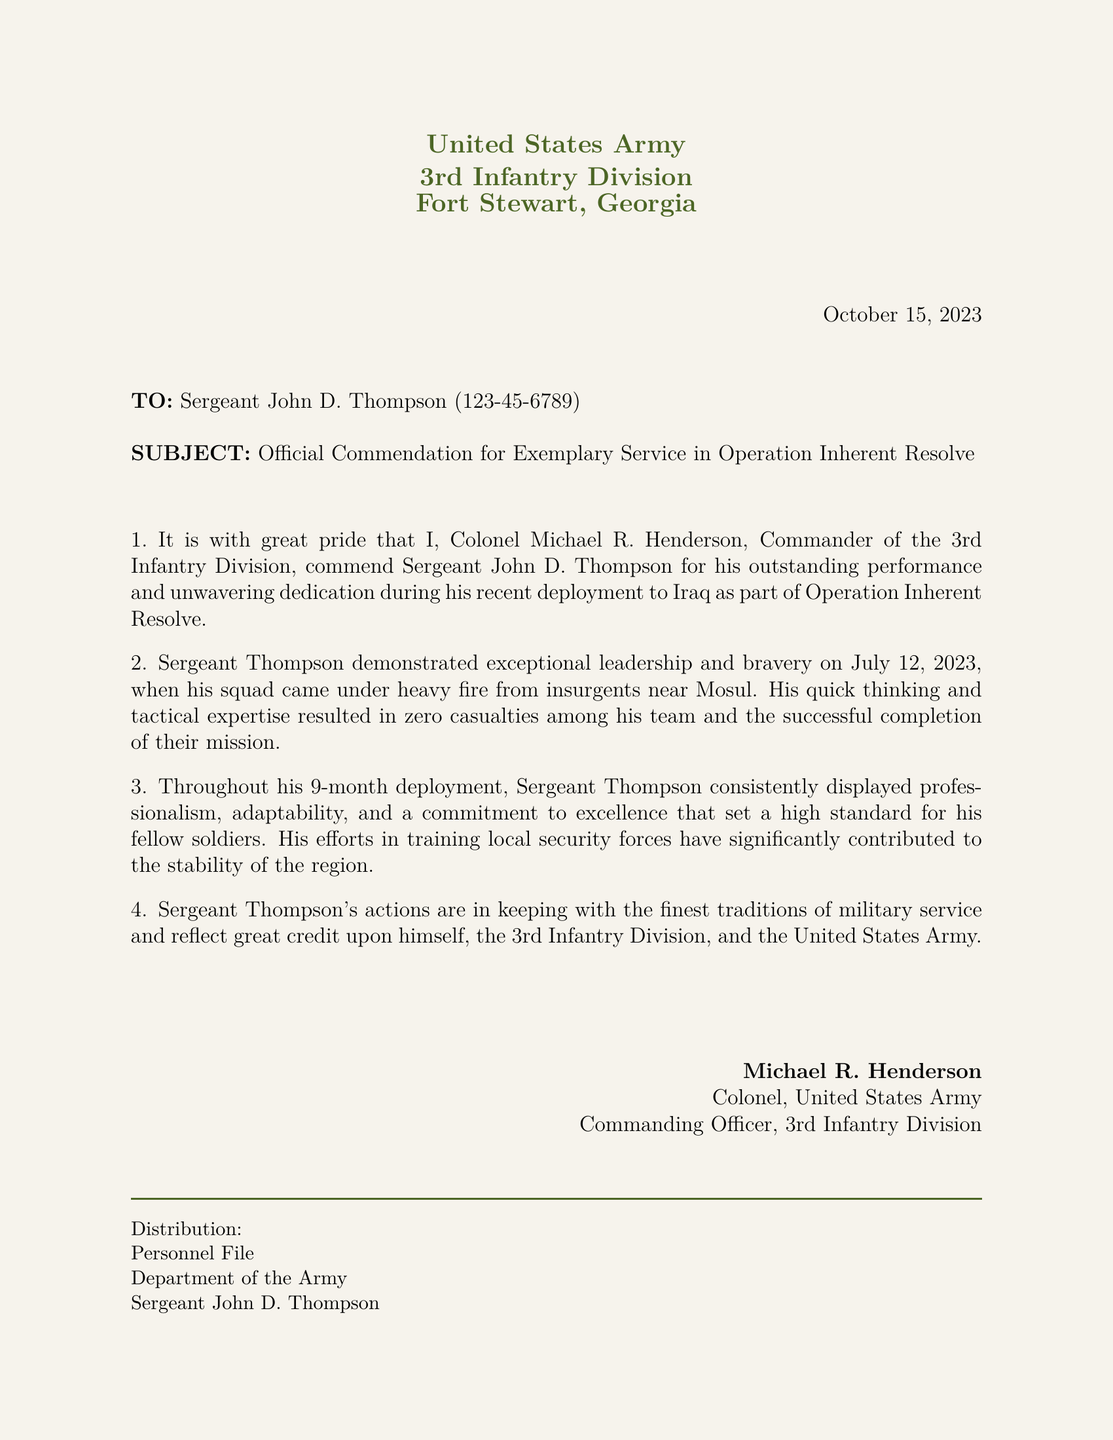What is the date of the commendation letter? The date is explicitly mentioned in the document, indicating when the letter was issued.
Answer: October 15, 2023 Who is the commanding officer? The document states the name of the commanding officer issuing the commendation.
Answer: Colonel Michael R. Henderson How long was Sergeant Thompson's deployment? The duration of the deployment is specified in the commendation letter.
Answer: 9 months What operation was Sergeant Thompson involved in? The operation for which the commendation is given is clearly stated.
Answer: Operation Inherent Resolve What was the location of the incident on July 12, 2023? The document provides the geographic context for the significant event involving Sergeant Thompson.
Answer: Mosul What was the outcome of the incident described in the letter? The letter notes the result of Sergeant Thompson's actions on the day of the incident.
Answer: Zero casualties What aspect of military service does Sergeant Thompson's actions reflect? This is highlighted in the conclusion of the commendation letter, indicating the qualities of his service.
Answer: Finest traditions of military service 